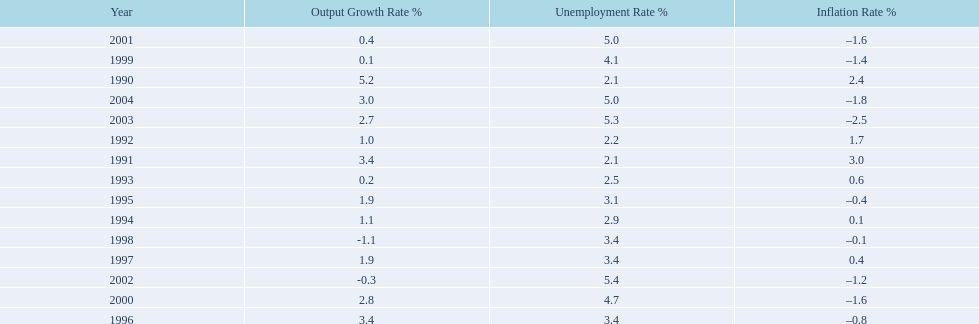Were the highest unemployment rates in japan before or after the year 2000? After. Would you mind parsing the complete table? {'header': ['Year', 'Output Growth Rate\xa0%', 'Unemployment Rate\xa0%', 'Inflation Rate\xa0%'], 'rows': [['2001', '0.4', '5.0', '–1.6'], ['1999', '0.1', '4.1', '–1.4'], ['1990', '5.2', '2.1', '2.4'], ['2004', '3.0', '5.0', '–1.8'], ['2003', '2.7', '5.3', '–2.5'], ['1992', '1.0', '2.2', '1.7'], ['1991', '3.4', '2.1', '3.0'], ['1993', '0.2', '2.5', '0.6'], ['1995', '1.9', '3.1', '–0.4'], ['1994', '1.1', '2.9', '0.1'], ['1998', '-1.1', '3.4', '–0.1'], ['1997', '1.9', '3.4', '0.4'], ['2002', '-0.3', '5.4', '–1.2'], ['2000', '2.8', '4.7', '–1.6'], ['1996', '3.4', '3.4', '–0.8']]} 